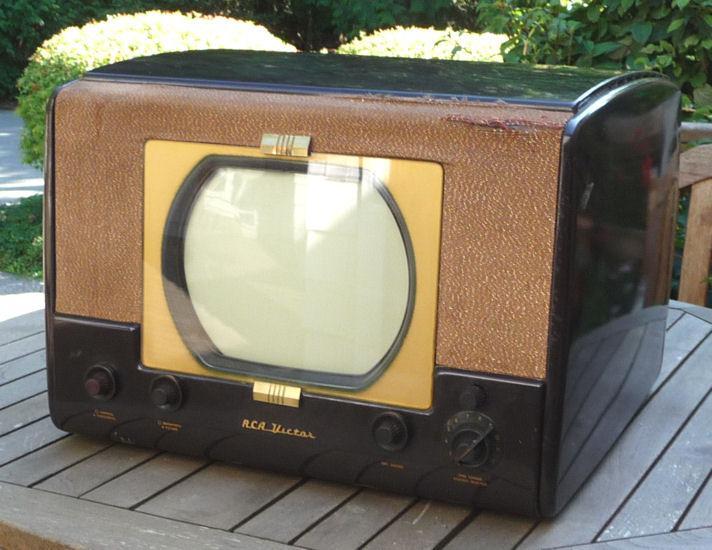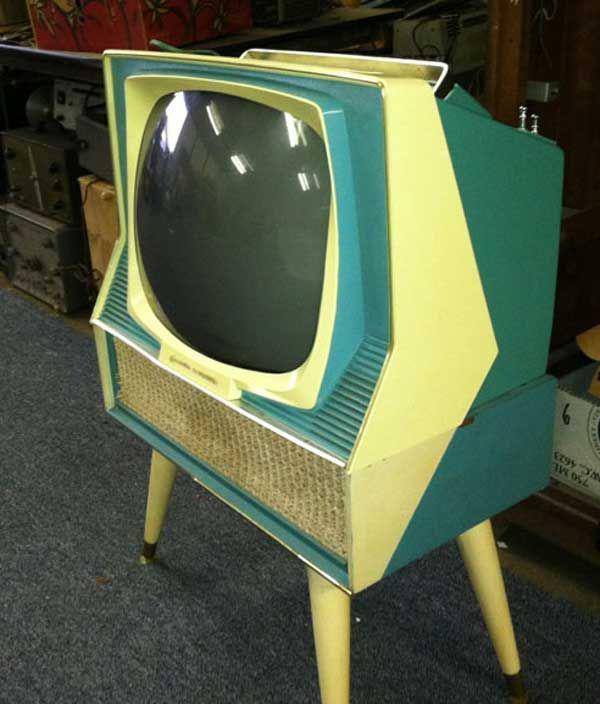The first image is the image on the left, the second image is the image on the right. For the images shown, is this caption "In one image, a television and a radio unit are housed in a long wooden console cabinet on short legs that has speakers on the front and end." true? Answer yes or no. No. The first image is the image on the left, the second image is the image on the right. For the images shown, is this caption "Exactly one TV has four legs sitting on a hard, non-grassy surface, and at least one TV has a screen with four rounded corners." true? Answer yes or no. Yes. 